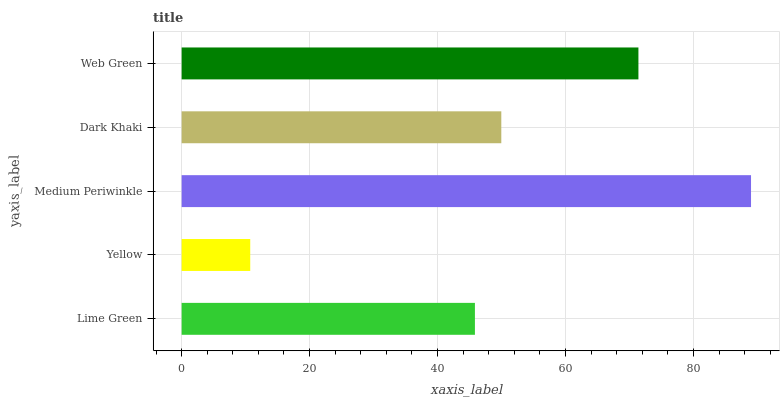Is Yellow the minimum?
Answer yes or no. Yes. Is Medium Periwinkle the maximum?
Answer yes or no. Yes. Is Medium Periwinkle the minimum?
Answer yes or no. No. Is Yellow the maximum?
Answer yes or no. No. Is Medium Periwinkle greater than Yellow?
Answer yes or no. Yes. Is Yellow less than Medium Periwinkle?
Answer yes or no. Yes. Is Yellow greater than Medium Periwinkle?
Answer yes or no. No. Is Medium Periwinkle less than Yellow?
Answer yes or no. No. Is Dark Khaki the high median?
Answer yes or no. Yes. Is Dark Khaki the low median?
Answer yes or no. Yes. Is Medium Periwinkle the high median?
Answer yes or no. No. Is Medium Periwinkle the low median?
Answer yes or no. No. 